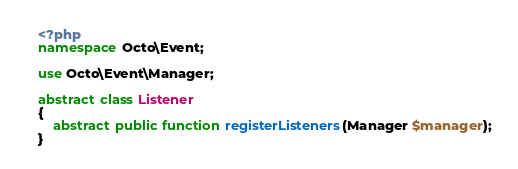Convert code to text. <code><loc_0><loc_0><loc_500><loc_500><_PHP_><?php
namespace Octo\Event;

use Octo\Event\Manager;

abstract class Listener
{
    abstract public function registerListeners(Manager $manager);
}
</code> 